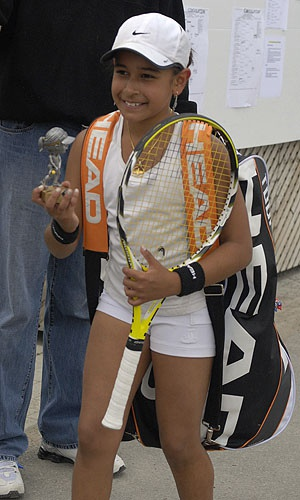Describe the objects in this image and their specific colors. I can see people in black, brown, darkgray, and maroon tones, people in black, gray, and darkblue tones, tennis racket in black, darkgray, tan, brown, and gray tones, and backpack in black, darkgray, gray, and lightgray tones in this image. 